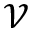<formula> <loc_0><loc_0><loc_500><loc_500>\mathcal { V }</formula> 